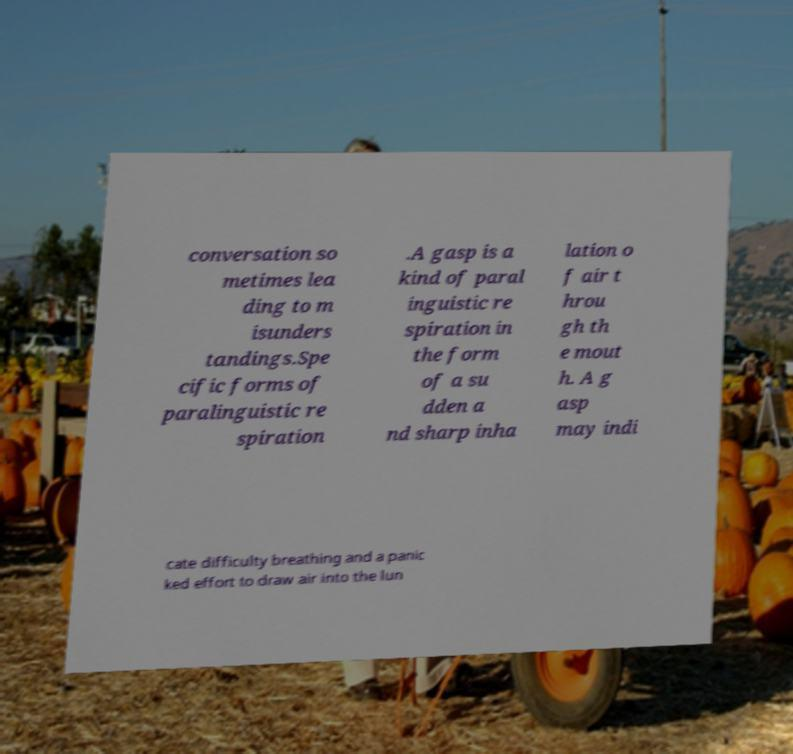There's text embedded in this image that I need extracted. Can you transcribe it verbatim? conversation so metimes lea ding to m isunders tandings.Spe cific forms of paralinguistic re spiration .A gasp is a kind of paral inguistic re spiration in the form of a su dden a nd sharp inha lation o f air t hrou gh th e mout h. A g asp may indi cate difficulty breathing and a panic ked effort to draw air into the lun 